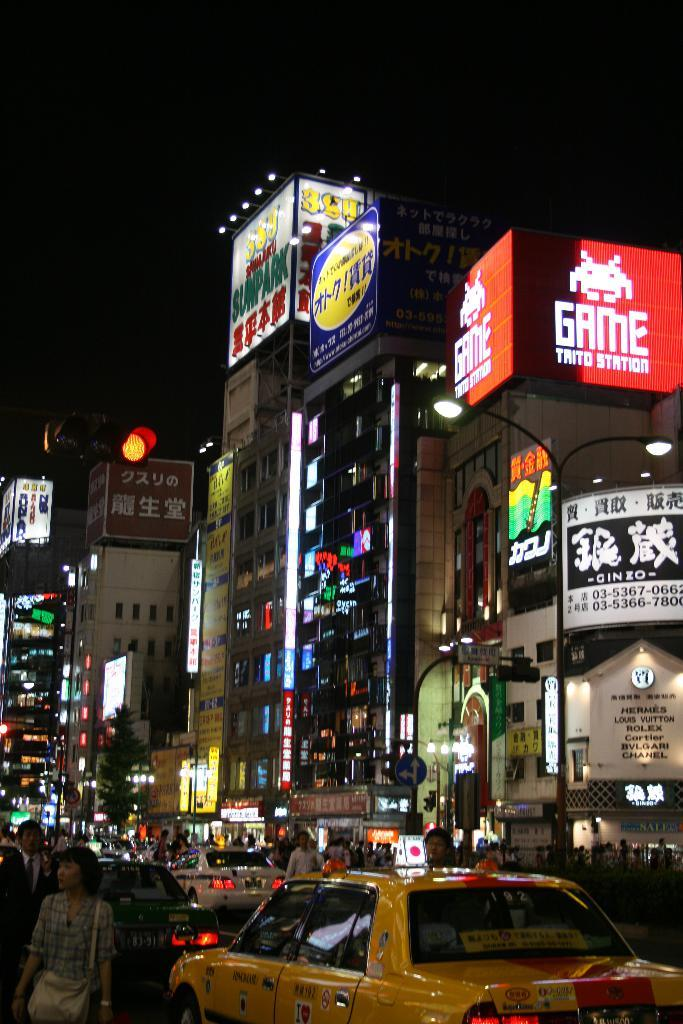What type of structures can be seen in the image? There are buildings in the image. Where is the traffic light located in the image? The traffic light is on the left side of the image. Can you describe the people visible in the image? There are people visible in the image. What type of vehicles are present on the road? Cars are present on the road. What is visible at the top of the image? The sky is visible at the top of the image. Can you tell me how many people are swimming in the image? There is no swimming activity depicted in the image; it features buildings, a traffic light, people, cars, and the sky. What type of suggestion is being made by the buildings in the image? Buildings do not make suggestions; they are inanimate structures. 